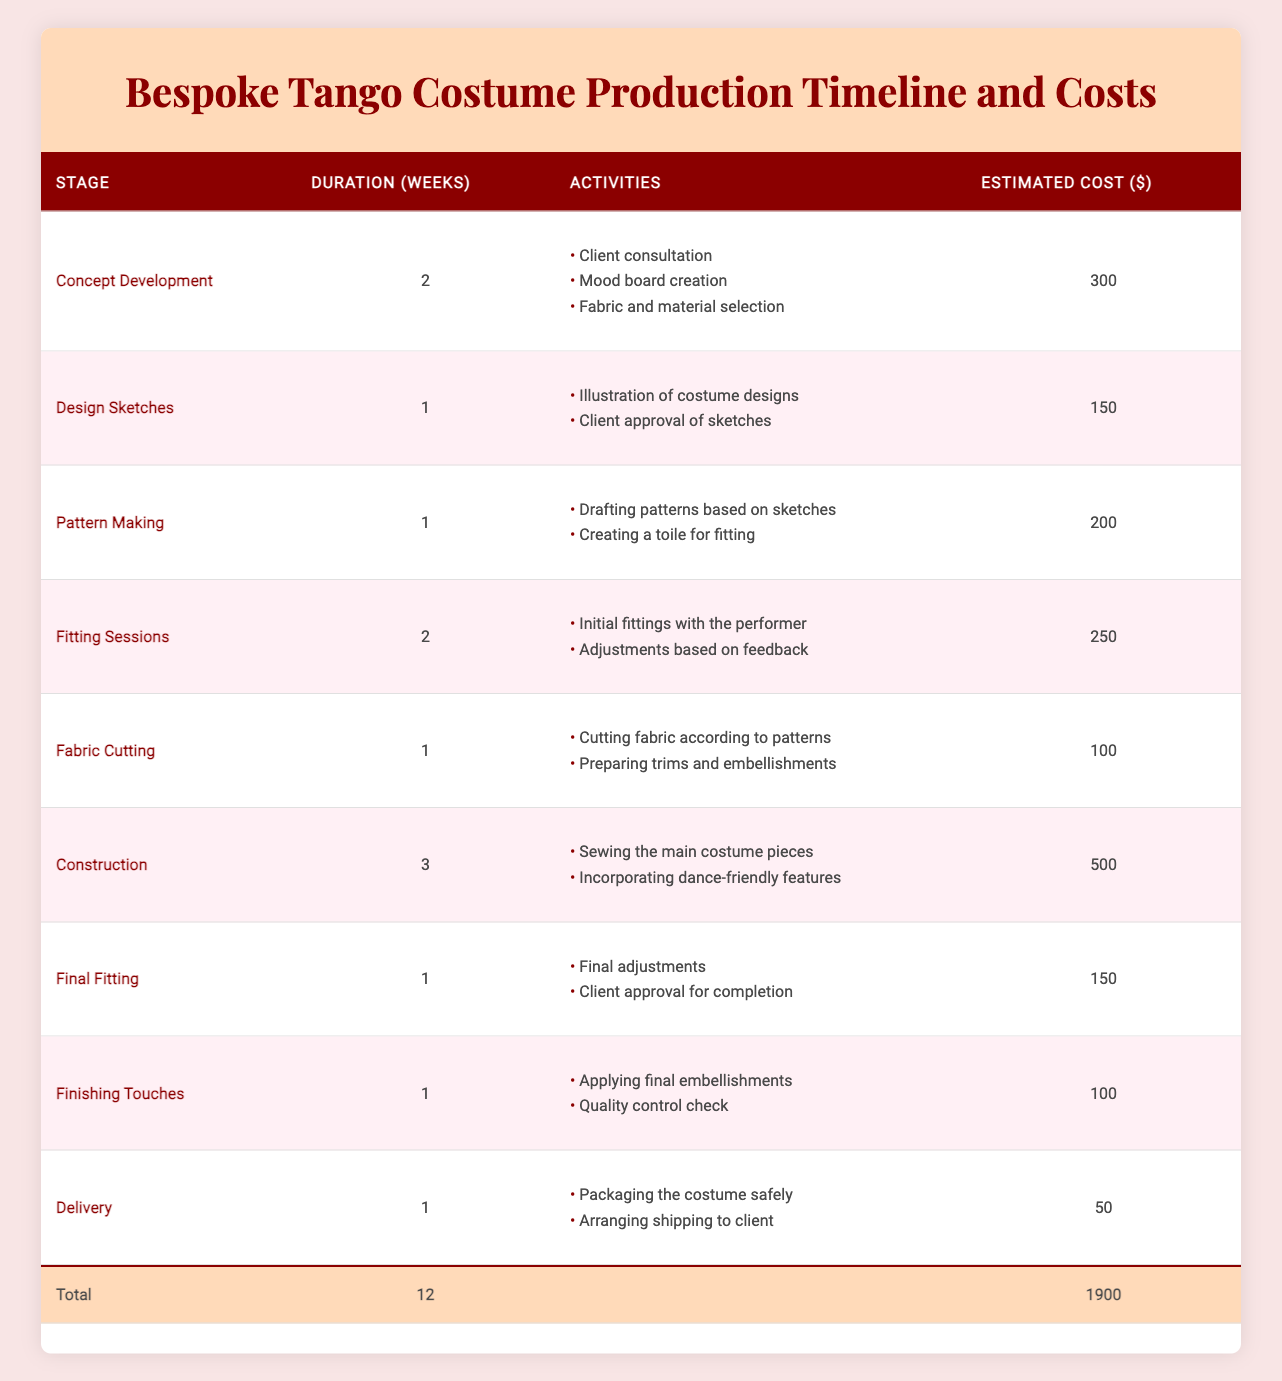What is the total estimated cost for producing a bespoke tango costume? The total estimated cost is provided directly in the table under the "Total" row, which shows $1900.
Answer: $1900 How long does the entire production process take? The total duration is listed in the table under the "Total" row, which indicates that it takes 12 weeks.
Answer: 12 weeks Which stage has the highest estimated cost? By reviewing the estimated costs for each stage, "Construction" has the highest cost at $500.
Answer: Construction What activities are involved in the "Fitting Sessions" stage? The activities for "Fitting Sessions" are listed in the table under that stage, which includes "Initial fittings with the performer" and "Adjustments based on feedback."
Answer: Initial fittings with the performer, Adjustments based on feedback How much does the "Delivery" stage cost? The cost for the "Delivery" stage is indicated in the table as $50.
Answer: $50 What is the average cost per stage of the production timeline? There are 9 stages total, and the total estimated cost is $1900. To find the average, divide $1900 by 9, which equals approximately $211.11.
Answer: Approximately $211.11 Is the duration of the "Construction" stage longer than the "Final Fitting" stage? The "Construction" stage lasts for 3 weeks, while the "Final Fitting" stage lasts for only 1 week, thus confirming that "Construction" is longer.
Answer: Yes What is the total duration of all stages that involve fitting? The "Fitting Sessions" take 2 weeks and the "Final Fitting" takes 1 week, so total duration is 2 + 1 = 3 weeks.
Answer: 3 weeks Which stage immediately follows "Pattern Making" in the timeline? According to the order in the table, the stage that follows "Pattern Making" is "Fitting Sessions."
Answer: Fitting Sessions How much cheaper is "Fabric Cutting" compared to "Construction"? The cost for "Fabric Cutting" is $100 and for "Construction" it is $500. The difference is $500 - $100 = $400.
Answer: $400 